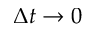Convert formula to latex. <formula><loc_0><loc_0><loc_500><loc_500>\Delta t \rightarrow 0</formula> 